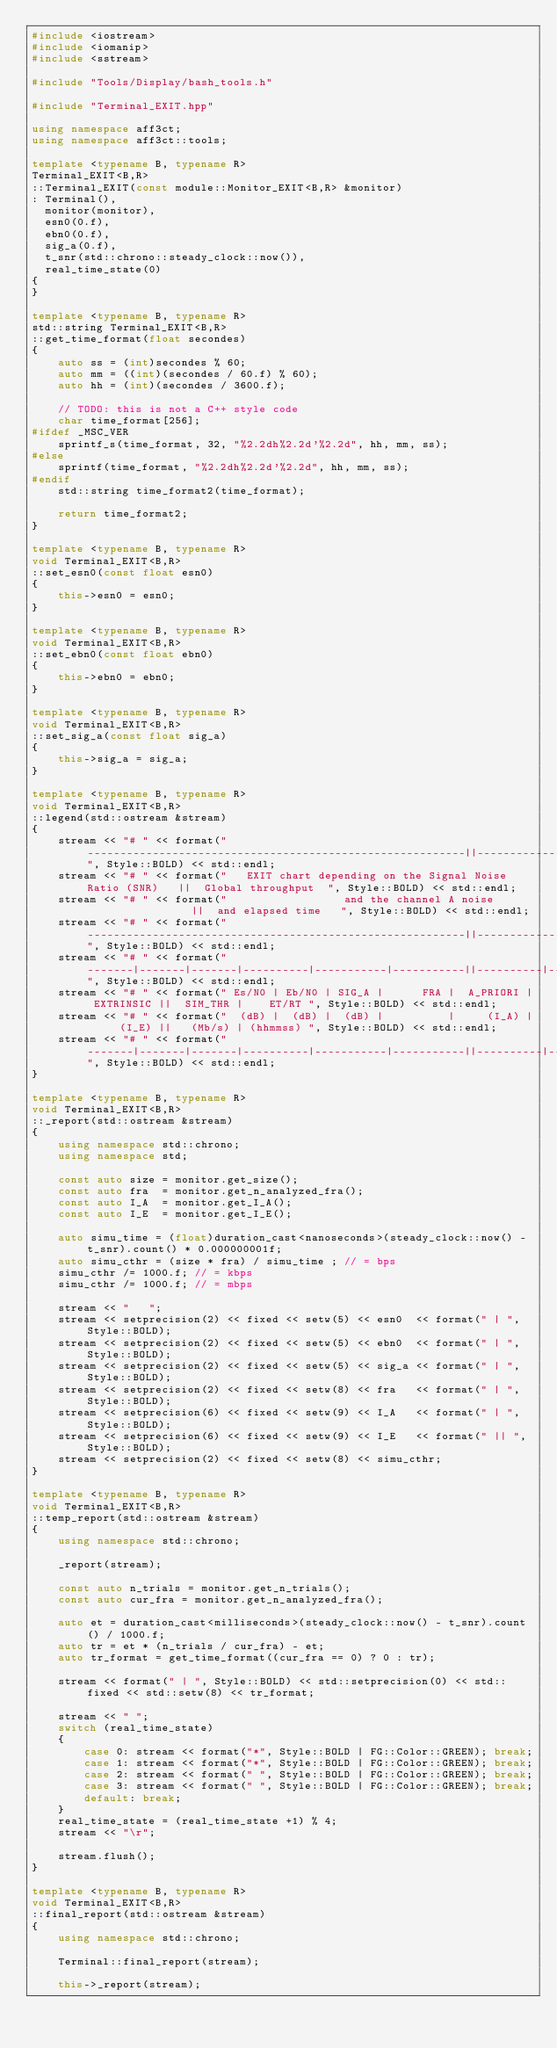Convert code to text. <code><loc_0><loc_0><loc_500><loc_500><_C++_>#include <iostream>
#include <iomanip>
#include <sstream>

#include "Tools/Display/bash_tools.h"

#include "Terminal_EXIT.hpp"

using namespace aff3ct;
using namespace aff3ct::tools;

template <typename B, typename R>
Terminal_EXIT<B,R>
::Terminal_EXIT(const module::Monitor_EXIT<B,R> &monitor)
: Terminal(),
  monitor(monitor),
  esn0(0.f),
  ebn0(0.f),
  sig_a(0.f),
  t_snr(std::chrono::steady_clock::now()),
  real_time_state(0)
{
}

template <typename B, typename R>
std::string Terminal_EXIT<B,R>
::get_time_format(float secondes)
{
	auto ss = (int)secondes % 60;
	auto mm = ((int)(secondes / 60.f) % 60);
	auto hh = (int)(secondes / 3600.f);

	// TODO: this is not a C++ style code
	char time_format[256];
#ifdef _MSC_VER
	sprintf_s(time_format, 32, "%2.2dh%2.2d'%2.2d", hh, mm, ss);
#else
	sprintf(time_format, "%2.2dh%2.2d'%2.2d", hh, mm, ss);
#endif
	std::string time_format2(time_format);

	return time_format2;
}

template <typename B, typename R>
void Terminal_EXIT<B,R>
::set_esn0(const float esn0)
{
	this->esn0 = esn0;
}

template <typename B, typename R>
void Terminal_EXIT<B,R>
::set_ebn0(const float ebn0)
{
	this->ebn0 = ebn0;
}

template <typename B, typename R>
void Terminal_EXIT<B,R>
::set_sig_a(const float sig_a)
{
	this->sig_a = sig_a;
}

template <typename B, typename R>
void Terminal_EXIT<B,R>
::legend(std::ostream &stream)
{
	stream << "# " << format("----------------------------------------------------------||---------------------", Style::BOLD) << std::endl;
	stream << "# " << format("   EXIT chart depending on the Signal Noise Ratio (SNR)   ||  Global throughput  ", Style::BOLD) << std::endl;
	stream << "# " << format("                  and the channel A noise                 ||  and elapsed time   ", Style::BOLD) << std::endl;
	stream << "# " << format("----------------------------------------------------------||---------------------", Style::BOLD) << std::endl;
	stream << "# " << format("-------|-------|-------|----------|-----------|-----------||----------|----------", Style::BOLD) << std::endl;
	stream << "# " << format(" Es/N0 | Eb/N0 | SIG_A |      FRA |  A_PRIORI | EXTRINSIC ||  SIM_THR |    ET/RT ", Style::BOLD) << std::endl;
	stream << "# " << format("  (dB) |  (dB) |  (dB) |          |     (I_A) |     (I_E) ||   (Mb/s) | (hhmmss) ", Style::BOLD) << std::endl;
	stream << "# " << format("-------|-------|-------|----------|-----------|-----------||----------|----------", Style::BOLD) << std::endl;
}

template <typename B, typename R>
void Terminal_EXIT<B,R>
::_report(std::ostream &stream)
{
	using namespace std::chrono;
	using namespace std;

	const auto size = monitor.get_size();
	const auto fra  = monitor.get_n_analyzed_fra();
	const auto I_A  = monitor.get_I_A();
	const auto I_E  = monitor.get_I_E();

	auto simu_time = (float)duration_cast<nanoseconds>(steady_clock::now() - t_snr).count() * 0.000000001f;
	auto simu_cthr = (size * fra) / simu_time ; // = bps
	simu_cthr /= 1000.f; // = kbps
	simu_cthr /= 1000.f; // = mbps

	stream << "   ";
	stream << setprecision(2) << fixed << setw(5) << esn0  << format(" | ",  Style::BOLD);
	stream << setprecision(2) << fixed << setw(5) << ebn0  << format(" | ",  Style::BOLD);
	stream << setprecision(2) << fixed << setw(5) << sig_a << format(" | ",  Style::BOLD);
	stream << setprecision(2) << fixed << setw(8) << fra   << format(" | ",  Style::BOLD);
	stream << setprecision(6) << fixed << setw(9) << I_A   << format(" | ",  Style::BOLD);
	stream << setprecision(6) << fixed << setw(9) << I_E   << format(" || ", Style::BOLD);
	stream << setprecision(2) << fixed << setw(8) << simu_cthr;
}

template <typename B, typename R>
void Terminal_EXIT<B,R>
::temp_report(std::ostream &stream)
{
	using namespace std::chrono;

	_report(stream);

	const auto n_trials = monitor.get_n_trials();
	const auto cur_fra = monitor.get_n_analyzed_fra();

	auto et = duration_cast<milliseconds>(steady_clock::now() - t_snr).count() / 1000.f;
	auto tr = et * (n_trials / cur_fra) - et;
	auto tr_format = get_time_format((cur_fra == 0) ? 0 : tr);

	stream << format(" | ", Style::BOLD) << std::setprecision(0) << std::fixed << std::setw(8) << tr_format;

	stream << " ";
	switch (real_time_state)
	{
		case 0: stream << format("*", Style::BOLD | FG::Color::GREEN); break;
		case 1: stream << format("*", Style::BOLD | FG::Color::GREEN); break;
		case 2: stream << format(" ", Style::BOLD | FG::Color::GREEN); break;
		case 3: stream << format(" ", Style::BOLD | FG::Color::GREEN); break;
		default: break;
	}
	real_time_state = (real_time_state +1) % 4;
	stream << "\r";

	stream.flush();
}

template <typename B, typename R>
void Terminal_EXIT<B,R>
::final_report(std::ostream &stream)
{
	using namespace std::chrono;

	Terminal::final_report(stream);

	this->_report(stream);
</code> 